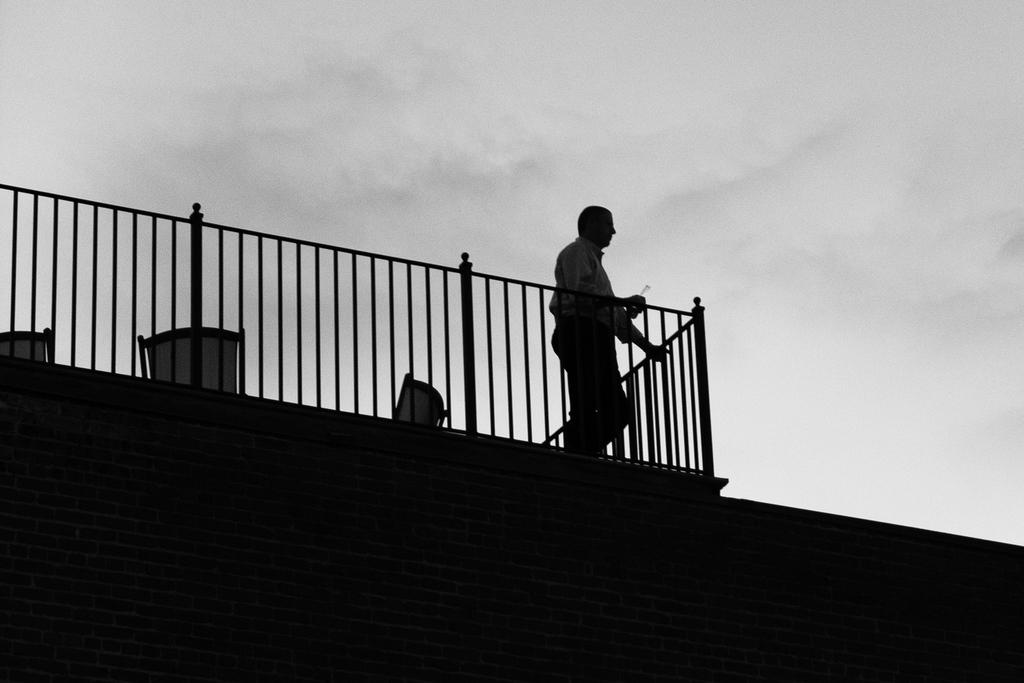What is the person in the image doing? There is a person standing on a building in the image. What can be seen in the background of the image? The sky is visible in the background of the image. What type of veil is the person wearing in the image? There is no veil present in the image; the person is simply standing on a building. 